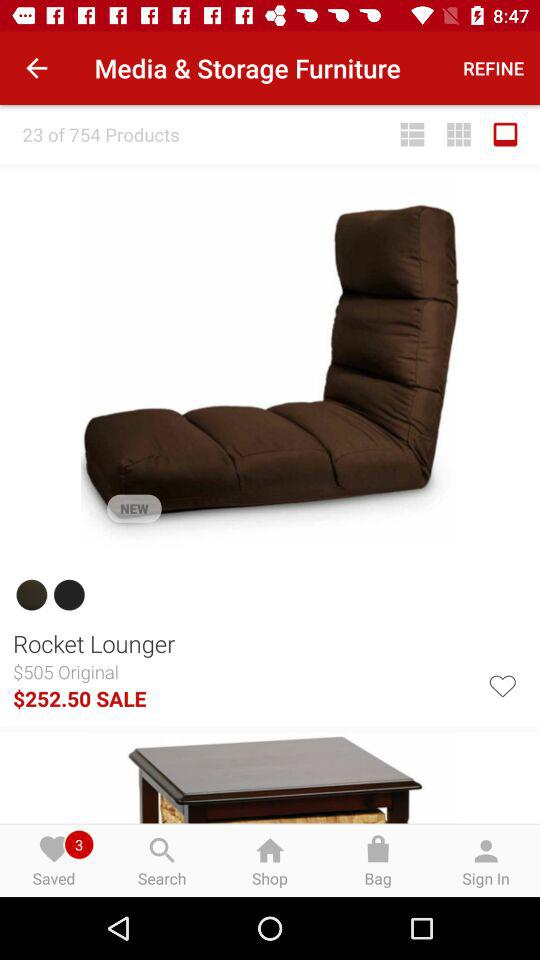What is the sale price of the Rocket Lounger?
Answer the question using a single word or phrase. $252.50 